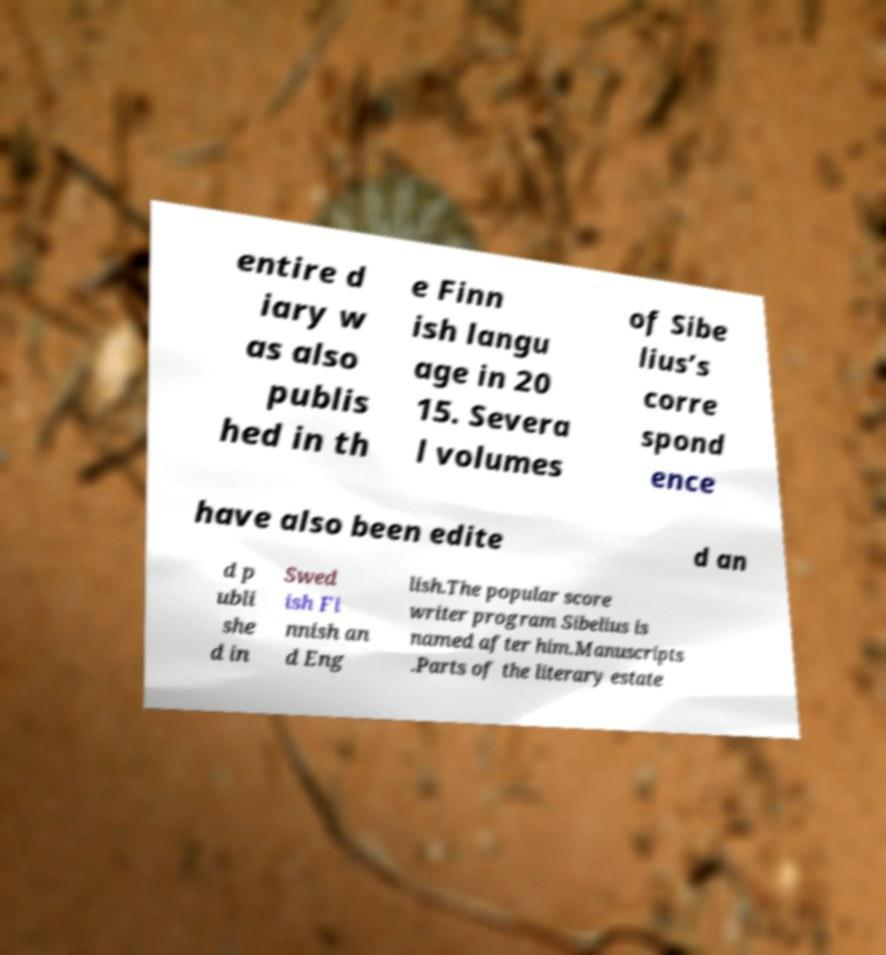Please read and relay the text visible in this image. What does it say? entire d iary w as also publis hed in th e Finn ish langu age in 20 15. Severa l volumes of Sibe lius’s corre spond ence have also been edite d an d p ubli she d in Swed ish Fi nnish an d Eng lish.The popular score writer program Sibelius is named after him.Manuscripts .Parts of the literary estate 